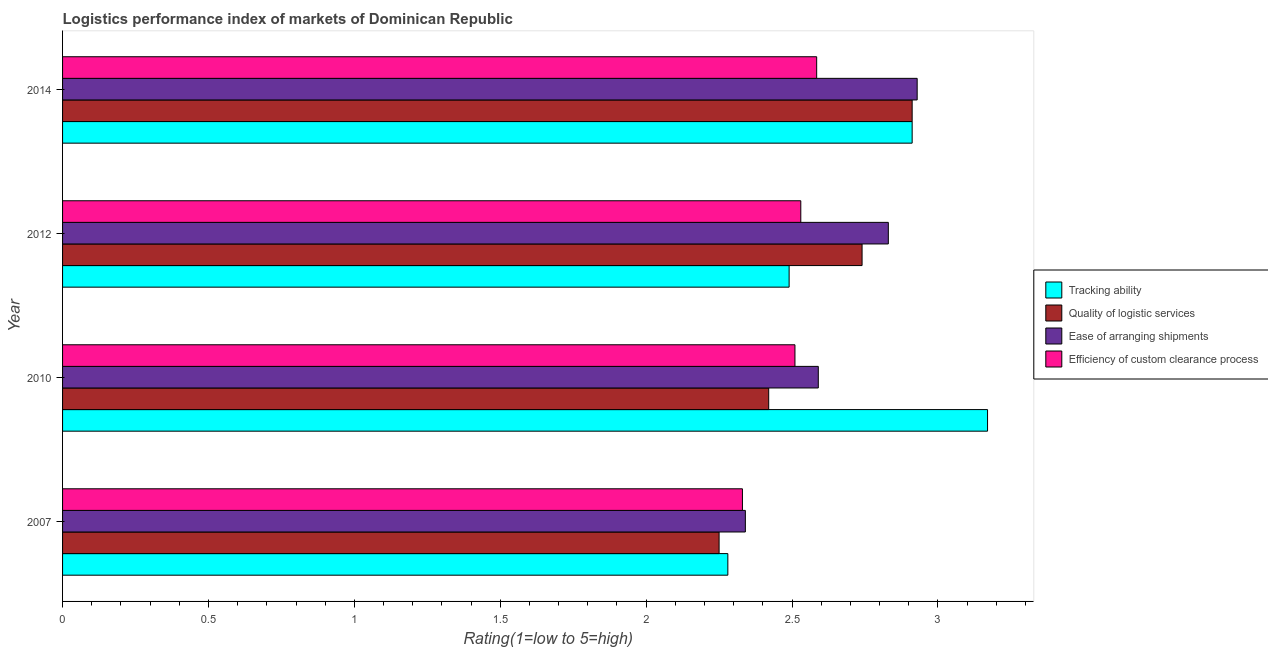How many different coloured bars are there?
Offer a terse response. 4. What is the label of the 4th group of bars from the top?
Provide a short and direct response. 2007. What is the lpi rating of tracking ability in 2014?
Provide a succinct answer. 2.91. Across all years, what is the maximum lpi rating of efficiency of custom clearance process?
Your response must be concise. 2.58. Across all years, what is the minimum lpi rating of tracking ability?
Offer a terse response. 2.28. In which year was the lpi rating of tracking ability maximum?
Give a very brief answer. 2010. What is the total lpi rating of tracking ability in the graph?
Keep it short and to the point. 10.85. What is the difference between the lpi rating of tracking ability in 2010 and that in 2014?
Provide a succinct answer. 0.26. What is the difference between the lpi rating of tracking ability in 2014 and the lpi rating of quality of logistic services in 2007?
Ensure brevity in your answer.  0.66. What is the average lpi rating of tracking ability per year?
Keep it short and to the point. 2.71. In the year 2014, what is the difference between the lpi rating of tracking ability and lpi rating of ease of arranging shipments?
Offer a terse response. -0.02. In how many years, is the lpi rating of ease of arranging shipments greater than 3.1 ?
Keep it short and to the point. 0. Is the lpi rating of efficiency of custom clearance process in 2010 less than that in 2012?
Your answer should be very brief. Yes. What is the difference between the highest and the second highest lpi rating of tracking ability?
Your answer should be compact. 0.26. What does the 2nd bar from the top in 2012 represents?
Make the answer very short. Ease of arranging shipments. What does the 1st bar from the bottom in 2012 represents?
Keep it short and to the point. Tracking ability. Is it the case that in every year, the sum of the lpi rating of tracking ability and lpi rating of quality of logistic services is greater than the lpi rating of ease of arranging shipments?
Offer a terse response. Yes. How many bars are there?
Ensure brevity in your answer.  16. Are all the bars in the graph horizontal?
Your response must be concise. Yes. Does the graph contain any zero values?
Give a very brief answer. No. Where does the legend appear in the graph?
Your answer should be compact. Center right. How many legend labels are there?
Give a very brief answer. 4. What is the title of the graph?
Your answer should be compact. Logistics performance index of markets of Dominican Republic. Does "Burnt food" appear as one of the legend labels in the graph?
Provide a short and direct response. No. What is the label or title of the X-axis?
Your answer should be very brief. Rating(1=low to 5=high). What is the label or title of the Y-axis?
Provide a short and direct response. Year. What is the Rating(1=low to 5=high) of Tracking ability in 2007?
Provide a short and direct response. 2.28. What is the Rating(1=low to 5=high) in Quality of logistic services in 2007?
Your response must be concise. 2.25. What is the Rating(1=low to 5=high) in Ease of arranging shipments in 2007?
Your answer should be very brief. 2.34. What is the Rating(1=low to 5=high) in Efficiency of custom clearance process in 2007?
Give a very brief answer. 2.33. What is the Rating(1=low to 5=high) in Tracking ability in 2010?
Provide a short and direct response. 3.17. What is the Rating(1=low to 5=high) in Quality of logistic services in 2010?
Your answer should be very brief. 2.42. What is the Rating(1=low to 5=high) of Ease of arranging shipments in 2010?
Keep it short and to the point. 2.59. What is the Rating(1=low to 5=high) of Efficiency of custom clearance process in 2010?
Give a very brief answer. 2.51. What is the Rating(1=low to 5=high) of Tracking ability in 2012?
Offer a terse response. 2.49. What is the Rating(1=low to 5=high) of Quality of logistic services in 2012?
Ensure brevity in your answer.  2.74. What is the Rating(1=low to 5=high) of Ease of arranging shipments in 2012?
Offer a terse response. 2.83. What is the Rating(1=low to 5=high) of Efficiency of custom clearance process in 2012?
Keep it short and to the point. 2.53. What is the Rating(1=low to 5=high) of Tracking ability in 2014?
Give a very brief answer. 2.91. What is the Rating(1=low to 5=high) of Quality of logistic services in 2014?
Provide a short and direct response. 2.91. What is the Rating(1=low to 5=high) of Ease of arranging shipments in 2014?
Keep it short and to the point. 2.93. What is the Rating(1=low to 5=high) of Efficiency of custom clearance process in 2014?
Provide a succinct answer. 2.58. Across all years, what is the maximum Rating(1=low to 5=high) of Tracking ability?
Your response must be concise. 3.17. Across all years, what is the maximum Rating(1=low to 5=high) of Quality of logistic services?
Offer a very short reply. 2.91. Across all years, what is the maximum Rating(1=low to 5=high) in Ease of arranging shipments?
Your answer should be compact. 2.93. Across all years, what is the maximum Rating(1=low to 5=high) in Efficiency of custom clearance process?
Keep it short and to the point. 2.58. Across all years, what is the minimum Rating(1=low to 5=high) in Tracking ability?
Your answer should be compact. 2.28. Across all years, what is the minimum Rating(1=low to 5=high) of Quality of logistic services?
Give a very brief answer. 2.25. Across all years, what is the minimum Rating(1=low to 5=high) of Ease of arranging shipments?
Make the answer very short. 2.34. Across all years, what is the minimum Rating(1=low to 5=high) of Efficiency of custom clearance process?
Your answer should be very brief. 2.33. What is the total Rating(1=low to 5=high) of Tracking ability in the graph?
Give a very brief answer. 10.85. What is the total Rating(1=low to 5=high) in Quality of logistic services in the graph?
Your response must be concise. 10.32. What is the total Rating(1=low to 5=high) of Ease of arranging shipments in the graph?
Ensure brevity in your answer.  10.69. What is the total Rating(1=low to 5=high) of Efficiency of custom clearance process in the graph?
Ensure brevity in your answer.  9.95. What is the difference between the Rating(1=low to 5=high) of Tracking ability in 2007 and that in 2010?
Offer a very short reply. -0.89. What is the difference between the Rating(1=low to 5=high) of Quality of logistic services in 2007 and that in 2010?
Make the answer very short. -0.17. What is the difference between the Rating(1=low to 5=high) in Efficiency of custom clearance process in 2007 and that in 2010?
Offer a very short reply. -0.18. What is the difference between the Rating(1=low to 5=high) in Tracking ability in 2007 and that in 2012?
Give a very brief answer. -0.21. What is the difference between the Rating(1=low to 5=high) of Quality of logistic services in 2007 and that in 2012?
Provide a short and direct response. -0.49. What is the difference between the Rating(1=low to 5=high) in Ease of arranging shipments in 2007 and that in 2012?
Provide a short and direct response. -0.49. What is the difference between the Rating(1=low to 5=high) in Tracking ability in 2007 and that in 2014?
Provide a short and direct response. -0.63. What is the difference between the Rating(1=low to 5=high) of Quality of logistic services in 2007 and that in 2014?
Provide a succinct answer. -0.66. What is the difference between the Rating(1=low to 5=high) in Ease of arranging shipments in 2007 and that in 2014?
Offer a terse response. -0.59. What is the difference between the Rating(1=low to 5=high) in Efficiency of custom clearance process in 2007 and that in 2014?
Provide a succinct answer. -0.25. What is the difference between the Rating(1=low to 5=high) in Tracking ability in 2010 and that in 2012?
Your answer should be very brief. 0.68. What is the difference between the Rating(1=low to 5=high) of Quality of logistic services in 2010 and that in 2012?
Provide a succinct answer. -0.32. What is the difference between the Rating(1=low to 5=high) in Ease of arranging shipments in 2010 and that in 2012?
Give a very brief answer. -0.24. What is the difference between the Rating(1=low to 5=high) of Efficiency of custom clearance process in 2010 and that in 2012?
Provide a short and direct response. -0.02. What is the difference between the Rating(1=low to 5=high) of Tracking ability in 2010 and that in 2014?
Keep it short and to the point. 0.26. What is the difference between the Rating(1=low to 5=high) in Quality of logistic services in 2010 and that in 2014?
Make the answer very short. -0.49. What is the difference between the Rating(1=low to 5=high) of Ease of arranging shipments in 2010 and that in 2014?
Your answer should be compact. -0.34. What is the difference between the Rating(1=low to 5=high) of Efficiency of custom clearance process in 2010 and that in 2014?
Make the answer very short. -0.07. What is the difference between the Rating(1=low to 5=high) of Tracking ability in 2012 and that in 2014?
Provide a short and direct response. -0.42. What is the difference between the Rating(1=low to 5=high) of Quality of logistic services in 2012 and that in 2014?
Provide a short and direct response. -0.17. What is the difference between the Rating(1=low to 5=high) in Ease of arranging shipments in 2012 and that in 2014?
Make the answer very short. -0.1. What is the difference between the Rating(1=low to 5=high) of Efficiency of custom clearance process in 2012 and that in 2014?
Offer a very short reply. -0.05. What is the difference between the Rating(1=low to 5=high) of Tracking ability in 2007 and the Rating(1=low to 5=high) of Quality of logistic services in 2010?
Provide a short and direct response. -0.14. What is the difference between the Rating(1=low to 5=high) in Tracking ability in 2007 and the Rating(1=low to 5=high) in Ease of arranging shipments in 2010?
Your response must be concise. -0.31. What is the difference between the Rating(1=low to 5=high) in Tracking ability in 2007 and the Rating(1=low to 5=high) in Efficiency of custom clearance process in 2010?
Keep it short and to the point. -0.23. What is the difference between the Rating(1=low to 5=high) of Quality of logistic services in 2007 and the Rating(1=low to 5=high) of Ease of arranging shipments in 2010?
Your answer should be compact. -0.34. What is the difference between the Rating(1=low to 5=high) of Quality of logistic services in 2007 and the Rating(1=low to 5=high) of Efficiency of custom clearance process in 2010?
Your answer should be very brief. -0.26. What is the difference between the Rating(1=low to 5=high) of Ease of arranging shipments in 2007 and the Rating(1=low to 5=high) of Efficiency of custom clearance process in 2010?
Your response must be concise. -0.17. What is the difference between the Rating(1=low to 5=high) of Tracking ability in 2007 and the Rating(1=low to 5=high) of Quality of logistic services in 2012?
Ensure brevity in your answer.  -0.46. What is the difference between the Rating(1=low to 5=high) in Tracking ability in 2007 and the Rating(1=low to 5=high) in Ease of arranging shipments in 2012?
Your answer should be very brief. -0.55. What is the difference between the Rating(1=low to 5=high) of Tracking ability in 2007 and the Rating(1=low to 5=high) of Efficiency of custom clearance process in 2012?
Your response must be concise. -0.25. What is the difference between the Rating(1=low to 5=high) in Quality of logistic services in 2007 and the Rating(1=low to 5=high) in Ease of arranging shipments in 2012?
Ensure brevity in your answer.  -0.58. What is the difference between the Rating(1=low to 5=high) of Quality of logistic services in 2007 and the Rating(1=low to 5=high) of Efficiency of custom clearance process in 2012?
Offer a very short reply. -0.28. What is the difference between the Rating(1=low to 5=high) of Ease of arranging shipments in 2007 and the Rating(1=low to 5=high) of Efficiency of custom clearance process in 2012?
Keep it short and to the point. -0.19. What is the difference between the Rating(1=low to 5=high) in Tracking ability in 2007 and the Rating(1=low to 5=high) in Quality of logistic services in 2014?
Offer a terse response. -0.63. What is the difference between the Rating(1=low to 5=high) in Tracking ability in 2007 and the Rating(1=low to 5=high) in Ease of arranging shipments in 2014?
Offer a terse response. -0.65. What is the difference between the Rating(1=low to 5=high) in Tracking ability in 2007 and the Rating(1=low to 5=high) in Efficiency of custom clearance process in 2014?
Give a very brief answer. -0.3. What is the difference between the Rating(1=low to 5=high) of Quality of logistic services in 2007 and the Rating(1=low to 5=high) of Ease of arranging shipments in 2014?
Ensure brevity in your answer.  -0.68. What is the difference between the Rating(1=low to 5=high) of Quality of logistic services in 2007 and the Rating(1=low to 5=high) of Efficiency of custom clearance process in 2014?
Offer a terse response. -0.33. What is the difference between the Rating(1=low to 5=high) of Ease of arranging shipments in 2007 and the Rating(1=low to 5=high) of Efficiency of custom clearance process in 2014?
Provide a succinct answer. -0.24. What is the difference between the Rating(1=low to 5=high) of Tracking ability in 2010 and the Rating(1=low to 5=high) of Quality of logistic services in 2012?
Provide a short and direct response. 0.43. What is the difference between the Rating(1=low to 5=high) in Tracking ability in 2010 and the Rating(1=low to 5=high) in Ease of arranging shipments in 2012?
Your answer should be very brief. 0.34. What is the difference between the Rating(1=low to 5=high) in Tracking ability in 2010 and the Rating(1=low to 5=high) in Efficiency of custom clearance process in 2012?
Provide a succinct answer. 0.64. What is the difference between the Rating(1=low to 5=high) in Quality of logistic services in 2010 and the Rating(1=low to 5=high) in Ease of arranging shipments in 2012?
Offer a very short reply. -0.41. What is the difference between the Rating(1=low to 5=high) of Quality of logistic services in 2010 and the Rating(1=low to 5=high) of Efficiency of custom clearance process in 2012?
Your answer should be very brief. -0.11. What is the difference between the Rating(1=low to 5=high) of Ease of arranging shipments in 2010 and the Rating(1=low to 5=high) of Efficiency of custom clearance process in 2012?
Your answer should be very brief. 0.06. What is the difference between the Rating(1=low to 5=high) of Tracking ability in 2010 and the Rating(1=low to 5=high) of Quality of logistic services in 2014?
Your response must be concise. 0.26. What is the difference between the Rating(1=low to 5=high) of Tracking ability in 2010 and the Rating(1=low to 5=high) of Ease of arranging shipments in 2014?
Your response must be concise. 0.24. What is the difference between the Rating(1=low to 5=high) of Tracking ability in 2010 and the Rating(1=low to 5=high) of Efficiency of custom clearance process in 2014?
Provide a succinct answer. 0.59. What is the difference between the Rating(1=low to 5=high) of Quality of logistic services in 2010 and the Rating(1=low to 5=high) of Ease of arranging shipments in 2014?
Provide a short and direct response. -0.51. What is the difference between the Rating(1=low to 5=high) of Quality of logistic services in 2010 and the Rating(1=low to 5=high) of Efficiency of custom clearance process in 2014?
Your answer should be very brief. -0.16. What is the difference between the Rating(1=low to 5=high) in Ease of arranging shipments in 2010 and the Rating(1=low to 5=high) in Efficiency of custom clearance process in 2014?
Ensure brevity in your answer.  0.01. What is the difference between the Rating(1=low to 5=high) of Tracking ability in 2012 and the Rating(1=low to 5=high) of Quality of logistic services in 2014?
Your response must be concise. -0.42. What is the difference between the Rating(1=low to 5=high) in Tracking ability in 2012 and the Rating(1=low to 5=high) in Ease of arranging shipments in 2014?
Provide a short and direct response. -0.44. What is the difference between the Rating(1=low to 5=high) in Tracking ability in 2012 and the Rating(1=low to 5=high) in Efficiency of custom clearance process in 2014?
Provide a succinct answer. -0.09. What is the difference between the Rating(1=low to 5=high) of Quality of logistic services in 2012 and the Rating(1=low to 5=high) of Ease of arranging shipments in 2014?
Offer a terse response. -0.19. What is the difference between the Rating(1=low to 5=high) of Quality of logistic services in 2012 and the Rating(1=low to 5=high) of Efficiency of custom clearance process in 2014?
Give a very brief answer. 0.16. What is the difference between the Rating(1=low to 5=high) in Ease of arranging shipments in 2012 and the Rating(1=low to 5=high) in Efficiency of custom clearance process in 2014?
Your answer should be compact. 0.25. What is the average Rating(1=low to 5=high) of Tracking ability per year?
Offer a terse response. 2.71. What is the average Rating(1=low to 5=high) of Quality of logistic services per year?
Your answer should be compact. 2.58. What is the average Rating(1=low to 5=high) of Ease of arranging shipments per year?
Your response must be concise. 2.67. What is the average Rating(1=low to 5=high) of Efficiency of custom clearance process per year?
Keep it short and to the point. 2.49. In the year 2007, what is the difference between the Rating(1=low to 5=high) in Tracking ability and Rating(1=low to 5=high) in Quality of logistic services?
Your answer should be compact. 0.03. In the year 2007, what is the difference between the Rating(1=low to 5=high) of Tracking ability and Rating(1=low to 5=high) of Ease of arranging shipments?
Offer a terse response. -0.06. In the year 2007, what is the difference between the Rating(1=low to 5=high) of Quality of logistic services and Rating(1=low to 5=high) of Ease of arranging shipments?
Your response must be concise. -0.09. In the year 2007, what is the difference between the Rating(1=low to 5=high) in Quality of logistic services and Rating(1=low to 5=high) in Efficiency of custom clearance process?
Offer a very short reply. -0.08. In the year 2007, what is the difference between the Rating(1=low to 5=high) in Ease of arranging shipments and Rating(1=low to 5=high) in Efficiency of custom clearance process?
Your response must be concise. 0.01. In the year 2010, what is the difference between the Rating(1=low to 5=high) in Tracking ability and Rating(1=low to 5=high) in Quality of logistic services?
Keep it short and to the point. 0.75. In the year 2010, what is the difference between the Rating(1=low to 5=high) in Tracking ability and Rating(1=low to 5=high) in Ease of arranging shipments?
Your answer should be compact. 0.58. In the year 2010, what is the difference between the Rating(1=low to 5=high) in Tracking ability and Rating(1=low to 5=high) in Efficiency of custom clearance process?
Ensure brevity in your answer.  0.66. In the year 2010, what is the difference between the Rating(1=low to 5=high) in Quality of logistic services and Rating(1=low to 5=high) in Ease of arranging shipments?
Provide a succinct answer. -0.17. In the year 2010, what is the difference between the Rating(1=low to 5=high) in Quality of logistic services and Rating(1=low to 5=high) in Efficiency of custom clearance process?
Give a very brief answer. -0.09. In the year 2012, what is the difference between the Rating(1=low to 5=high) of Tracking ability and Rating(1=low to 5=high) of Quality of logistic services?
Ensure brevity in your answer.  -0.25. In the year 2012, what is the difference between the Rating(1=low to 5=high) of Tracking ability and Rating(1=low to 5=high) of Ease of arranging shipments?
Keep it short and to the point. -0.34. In the year 2012, what is the difference between the Rating(1=low to 5=high) of Tracking ability and Rating(1=low to 5=high) of Efficiency of custom clearance process?
Your answer should be compact. -0.04. In the year 2012, what is the difference between the Rating(1=low to 5=high) of Quality of logistic services and Rating(1=low to 5=high) of Ease of arranging shipments?
Give a very brief answer. -0.09. In the year 2012, what is the difference between the Rating(1=low to 5=high) of Quality of logistic services and Rating(1=low to 5=high) of Efficiency of custom clearance process?
Provide a succinct answer. 0.21. In the year 2014, what is the difference between the Rating(1=low to 5=high) in Tracking ability and Rating(1=low to 5=high) in Quality of logistic services?
Keep it short and to the point. 0. In the year 2014, what is the difference between the Rating(1=low to 5=high) of Tracking ability and Rating(1=low to 5=high) of Ease of arranging shipments?
Keep it short and to the point. -0.02. In the year 2014, what is the difference between the Rating(1=low to 5=high) of Tracking ability and Rating(1=low to 5=high) of Efficiency of custom clearance process?
Provide a short and direct response. 0.33. In the year 2014, what is the difference between the Rating(1=low to 5=high) of Quality of logistic services and Rating(1=low to 5=high) of Ease of arranging shipments?
Provide a succinct answer. -0.02. In the year 2014, what is the difference between the Rating(1=low to 5=high) of Quality of logistic services and Rating(1=low to 5=high) of Efficiency of custom clearance process?
Offer a very short reply. 0.33. In the year 2014, what is the difference between the Rating(1=low to 5=high) of Ease of arranging shipments and Rating(1=low to 5=high) of Efficiency of custom clearance process?
Keep it short and to the point. 0.34. What is the ratio of the Rating(1=low to 5=high) of Tracking ability in 2007 to that in 2010?
Provide a succinct answer. 0.72. What is the ratio of the Rating(1=low to 5=high) in Quality of logistic services in 2007 to that in 2010?
Your answer should be compact. 0.93. What is the ratio of the Rating(1=low to 5=high) in Ease of arranging shipments in 2007 to that in 2010?
Your answer should be very brief. 0.9. What is the ratio of the Rating(1=low to 5=high) in Efficiency of custom clearance process in 2007 to that in 2010?
Your response must be concise. 0.93. What is the ratio of the Rating(1=low to 5=high) in Tracking ability in 2007 to that in 2012?
Ensure brevity in your answer.  0.92. What is the ratio of the Rating(1=low to 5=high) of Quality of logistic services in 2007 to that in 2012?
Make the answer very short. 0.82. What is the ratio of the Rating(1=low to 5=high) of Ease of arranging shipments in 2007 to that in 2012?
Make the answer very short. 0.83. What is the ratio of the Rating(1=low to 5=high) of Efficiency of custom clearance process in 2007 to that in 2012?
Your answer should be very brief. 0.92. What is the ratio of the Rating(1=low to 5=high) of Tracking ability in 2007 to that in 2014?
Keep it short and to the point. 0.78. What is the ratio of the Rating(1=low to 5=high) of Quality of logistic services in 2007 to that in 2014?
Ensure brevity in your answer.  0.77. What is the ratio of the Rating(1=low to 5=high) of Ease of arranging shipments in 2007 to that in 2014?
Provide a short and direct response. 0.8. What is the ratio of the Rating(1=low to 5=high) of Efficiency of custom clearance process in 2007 to that in 2014?
Offer a very short reply. 0.9. What is the ratio of the Rating(1=low to 5=high) of Tracking ability in 2010 to that in 2012?
Give a very brief answer. 1.27. What is the ratio of the Rating(1=low to 5=high) in Quality of logistic services in 2010 to that in 2012?
Make the answer very short. 0.88. What is the ratio of the Rating(1=low to 5=high) in Ease of arranging shipments in 2010 to that in 2012?
Provide a short and direct response. 0.92. What is the ratio of the Rating(1=low to 5=high) of Efficiency of custom clearance process in 2010 to that in 2012?
Offer a very short reply. 0.99. What is the ratio of the Rating(1=low to 5=high) in Tracking ability in 2010 to that in 2014?
Provide a succinct answer. 1.09. What is the ratio of the Rating(1=low to 5=high) in Quality of logistic services in 2010 to that in 2014?
Provide a short and direct response. 0.83. What is the ratio of the Rating(1=low to 5=high) in Ease of arranging shipments in 2010 to that in 2014?
Offer a very short reply. 0.88. What is the ratio of the Rating(1=low to 5=high) of Efficiency of custom clearance process in 2010 to that in 2014?
Provide a short and direct response. 0.97. What is the ratio of the Rating(1=low to 5=high) in Tracking ability in 2012 to that in 2014?
Keep it short and to the point. 0.86. What is the ratio of the Rating(1=low to 5=high) in Quality of logistic services in 2012 to that in 2014?
Your answer should be compact. 0.94. What is the ratio of the Rating(1=low to 5=high) in Ease of arranging shipments in 2012 to that in 2014?
Provide a short and direct response. 0.97. What is the ratio of the Rating(1=low to 5=high) of Efficiency of custom clearance process in 2012 to that in 2014?
Your response must be concise. 0.98. What is the difference between the highest and the second highest Rating(1=low to 5=high) of Tracking ability?
Offer a very short reply. 0.26. What is the difference between the highest and the second highest Rating(1=low to 5=high) of Quality of logistic services?
Your answer should be compact. 0.17. What is the difference between the highest and the second highest Rating(1=low to 5=high) of Ease of arranging shipments?
Ensure brevity in your answer.  0.1. What is the difference between the highest and the second highest Rating(1=low to 5=high) in Efficiency of custom clearance process?
Make the answer very short. 0.05. What is the difference between the highest and the lowest Rating(1=low to 5=high) of Tracking ability?
Offer a terse response. 0.89. What is the difference between the highest and the lowest Rating(1=low to 5=high) in Quality of logistic services?
Keep it short and to the point. 0.66. What is the difference between the highest and the lowest Rating(1=low to 5=high) of Ease of arranging shipments?
Your answer should be compact. 0.59. What is the difference between the highest and the lowest Rating(1=low to 5=high) of Efficiency of custom clearance process?
Your response must be concise. 0.25. 